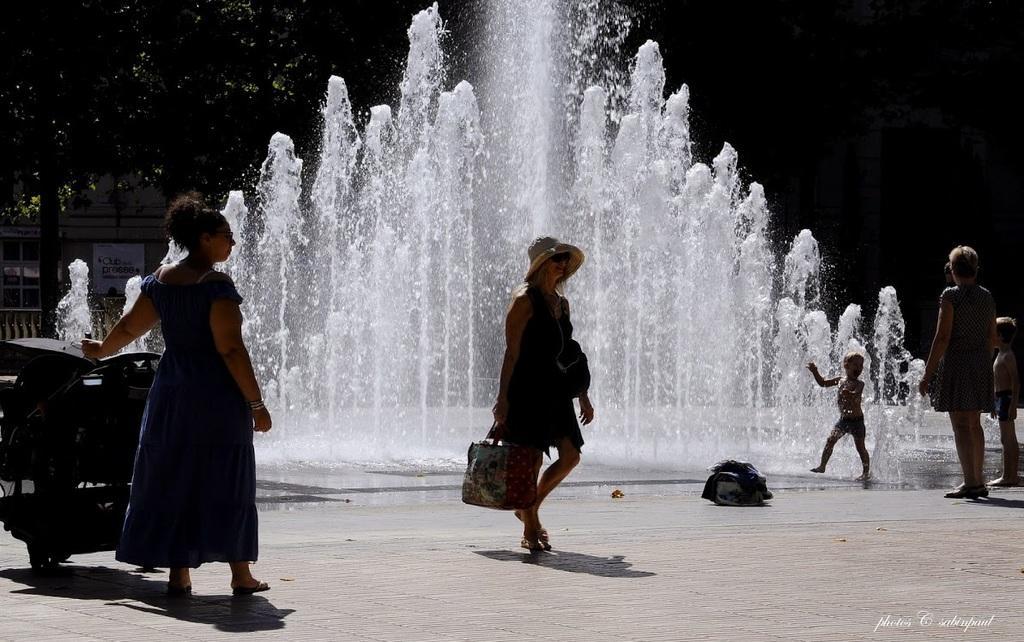Please provide a concise description of this image. In the image there are few ladies standing on the floor. On the left side of the image there is a machine. And behind them there are fountains. In the background there are trees and also there are few buildings. 